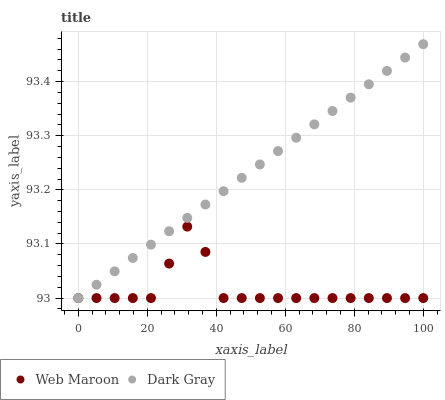Does Web Maroon have the minimum area under the curve?
Answer yes or no. Yes. Does Dark Gray have the maximum area under the curve?
Answer yes or no. Yes. Does Web Maroon have the maximum area under the curve?
Answer yes or no. No. Is Dark Gray the smoothest?
Answer yes or no. Yes. Is Web Maroon the roughest?
Answer yes or no. Yes. Is Web Maroon the smoothest?
Answer yes or no. No. Does Dark Gray have the lowest value?
Answer yes or no. Yes. Does Dark Gray have the highest value?
Answer yes or no. Yes. Does Web Maroon have the highest value?
Answer yes or no. No. Does Dark Gray intersect Web Maroon?
Answer yes or no. Yes. Is Dark Gray less than Web Maroon?
Answer yes or no. No. Is Dark Gray greater than Web Maroon?
Answer yes or no. No. 